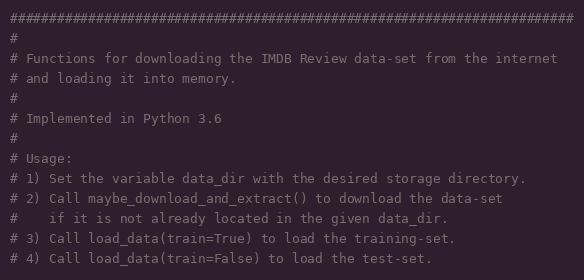<code> <loc_0><loc_0><loc_500><loc_500><_Python_>########################################################################
#
# Functions for downloading the IMDB Review data-set from the internet
# and loading it into memory.
#
# Implemented in Python 3.6
#
# Usage:
# 1) Set the variable data_dir with the desired storage directory.
# 2) Call maybe_download_and_extract() to download the data-set
#    if it is not already located in the given data_dir.
# 3) Call load_data(train=True) to load the training-set.
# 4) Call load_data(train=False) to load the test-set.</code> 